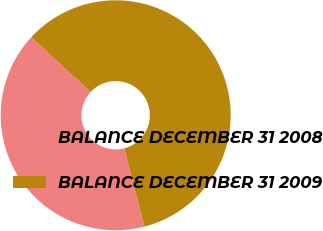Convert chart. <chart><loc_0><loc_0><loc_500><loc_500><pie_chart><fcel>BALANCE DECEMBER 31 2008<fcel>BALANCE DECEMBER 31 2009<nl><fcel>40.9%<fcel>59.1%<nl></chart> 